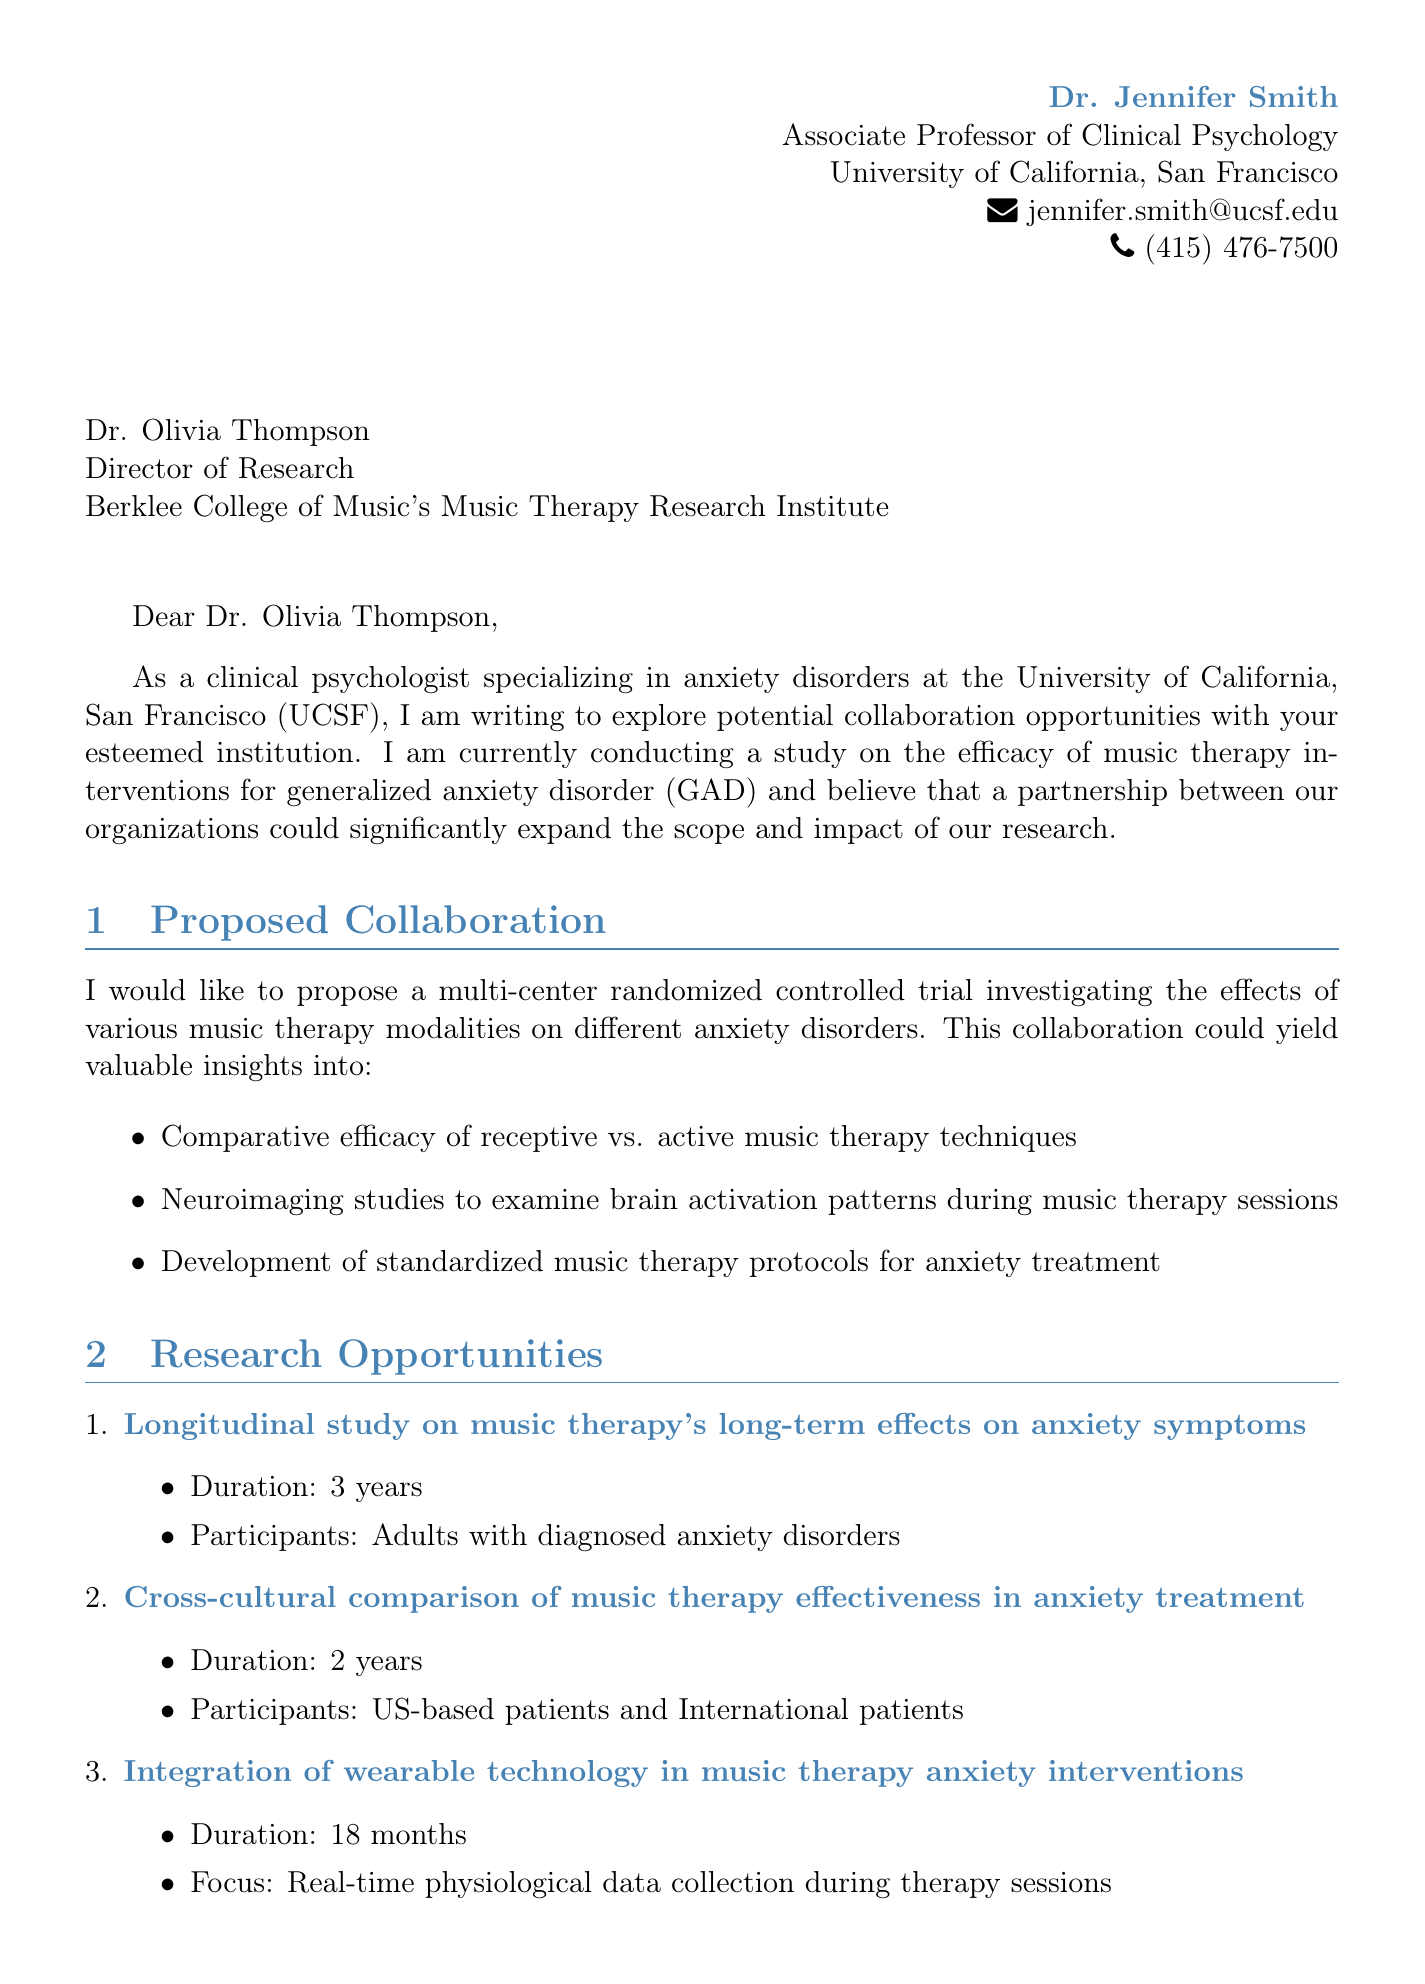What is the name of the recipient? The recipient's name is provided in the salutation of the letter.
Answer: Dr. Olivia Thompson What is the main research focus of Dr. Jennifer Smith? The introduction specifies the current research Dr. Smith is conducting.
Answer: Efficacy of music therapy interventions for generalized anxiety disorder How long is the proposed longitudinal study duration? The document lists the duration for the longitudinal study under research opportunities.
Answer: 3 years What is the potential funding amount for the NIH R01 Research Project Grant? The funding prospects section includes the funding amount for this grant.
Answer: $2.5 million over 5 years What is the initial meeting timeframe proposed by Dr. Jennifer Smith? The proposed timeline details when the initial meeting should take place.
Answer: Within the next month What kind of collaboration is being proposed? The proposed collaboration section outlines the type of study being suggested.
Answer: Multi-center randomized controlled trial Which institution is Dr. Jennifer Smith affiliated with? The closing section of the letter mentions her affiliation.
Answer: University of California, San Francisco What is the expected duration for integrating wearable technology in music therapy? This study duration is provided in the research opportunities section.
Answer: 18 months What type of letter is Dr. Smith writing? The document's structure indicates its purpose and context.
Answer: Request for collaboration 